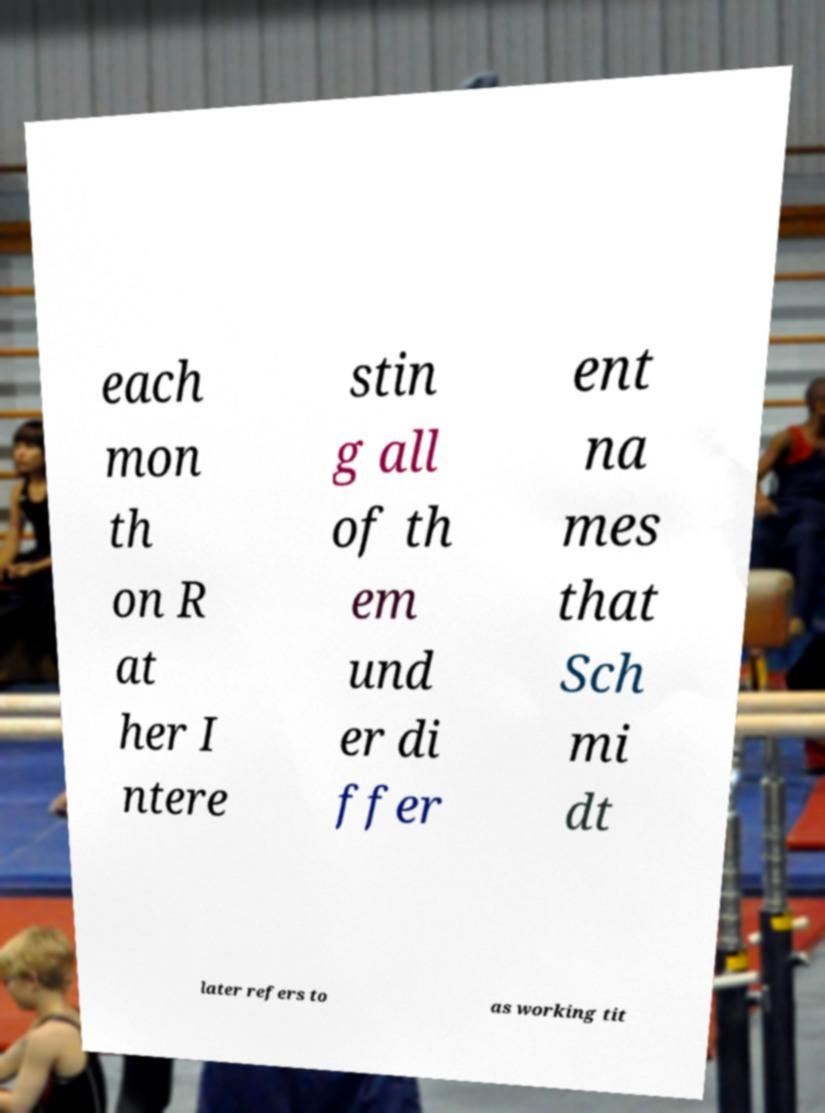I need the written content from this picture converted into text. Can you do that? each mon th on R at her I ntere stin g all of th em und er di ffer ent na mes that Sch mi dt later refers to as working tit 